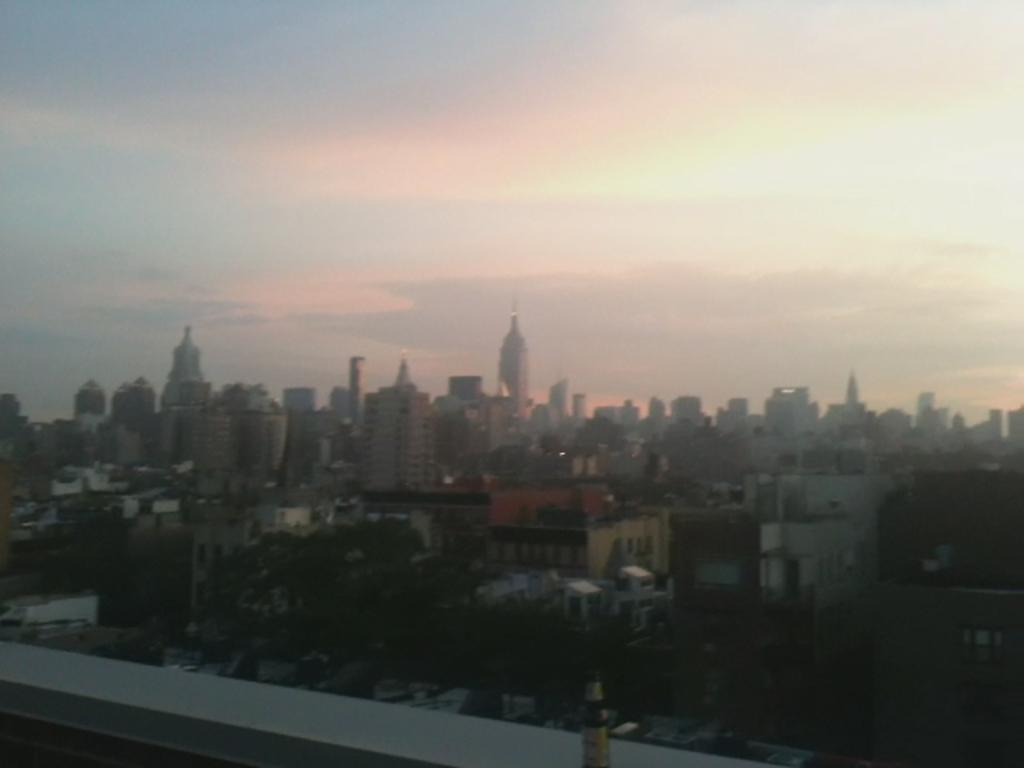What types of structures are present in the image? There are buildings and houses in the image. What other elements can be seen in the image besides structures? There are trees in the image. What is visible in the sky in the image? There are clouds visible in the sky in the image. How many chairs are placed around the egg in the image? There are no chairs or eggs present in the image. 